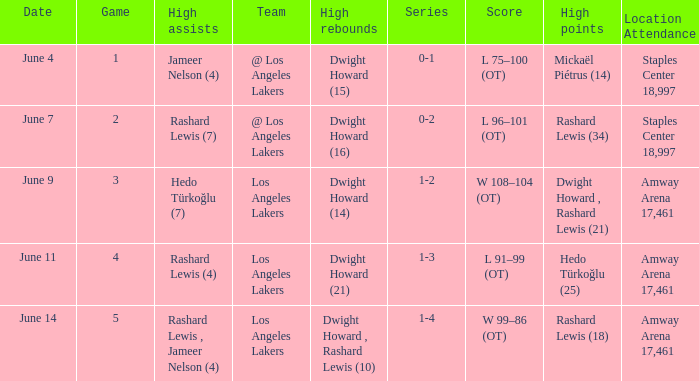What is the highest Game, when High Assists is "Hedo Türkoğlu (7)"? 3.0. 